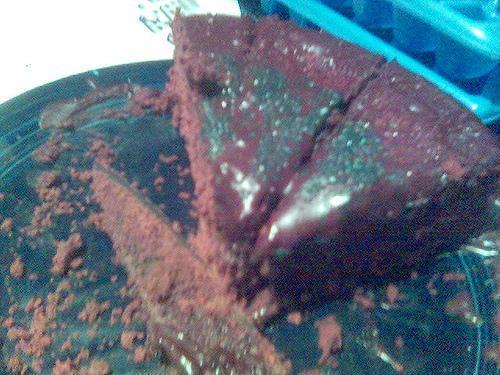How many slices are left?
Give a very brief answer. 2. How many cakes are there?
Give a very brief answer. 1. 